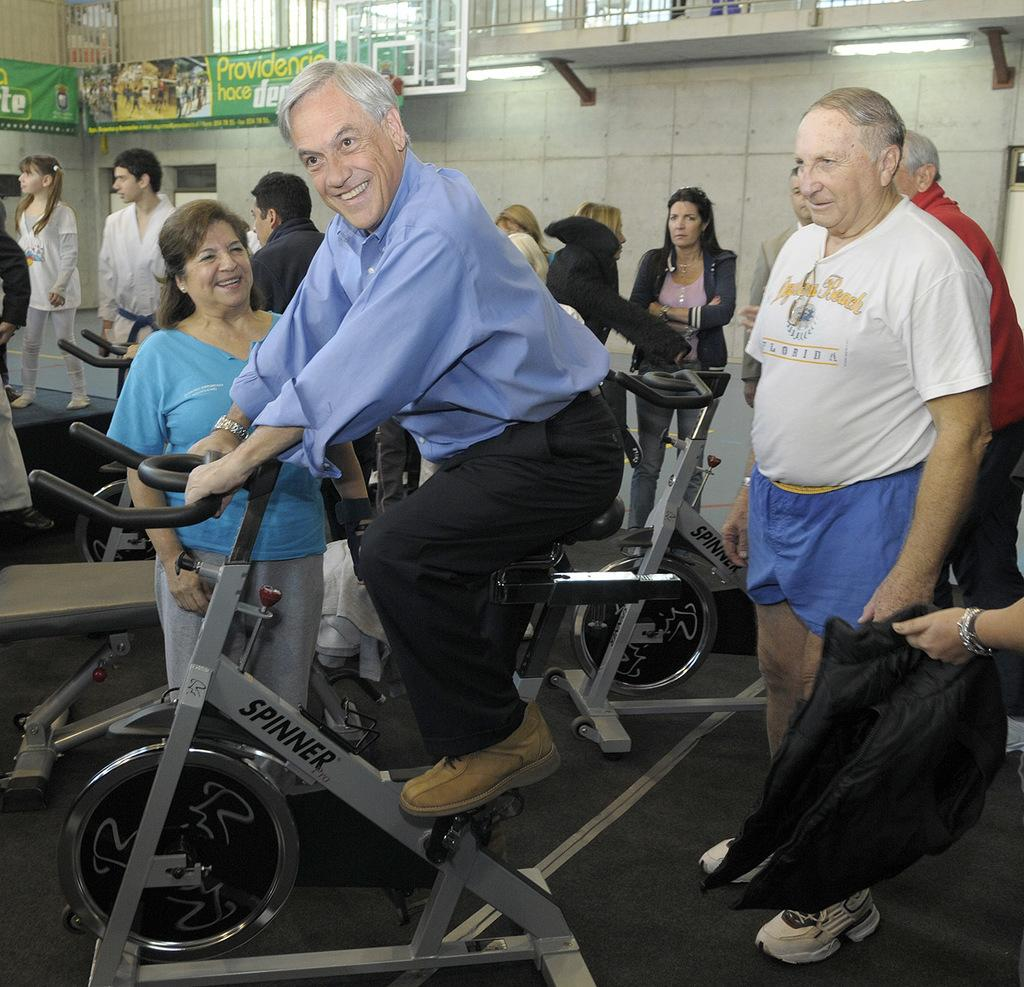What is the person in the image doing? The person is cycling in the image. How does the person appear to feel while cycling? The person is smiling, which suggests they are happy or enjoying themselves. Are there any other people present in the image? Yes, there are people in the image. What can be seen in the background of the image? There is a text banner in the background of the image. What type of fuel is the person using to power their bicycle in the image? The image does not provide information about the type of fuel being used to power the bicycle. 